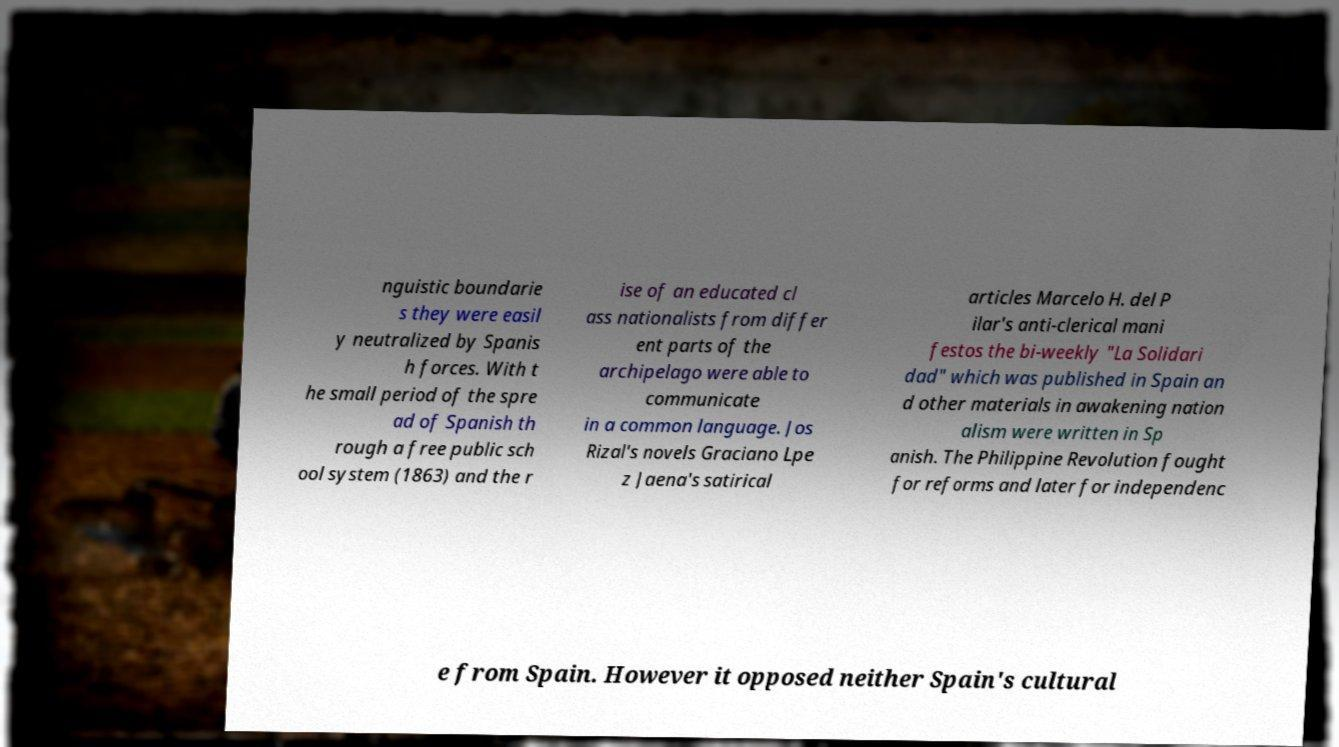There's text embedded in this image that I need extracted. Can you transcribe it verbatim? nguistic boundarie s they were easil y neutralized by Spanis h forces. With t he small period of the spre ad of Spanish th rough a free public sch ool system (1863) and the r ise of an educated cl ass nationalists from differ ent parts of the archipelago were able to communicate in a common language. Jos Rizal's novels Graciano Lpe z Jaena's satirical articles Marcelo H. del P ilar's anti-clerical mani festos the bi-weekly "La Solidari dad" which was published in Spain an d other materials in awakening nation alism were written in Sp anish. The Philippine Revolution fought for reforms and later for independenc e from Spain. However it opposed neither Spain's cultural 